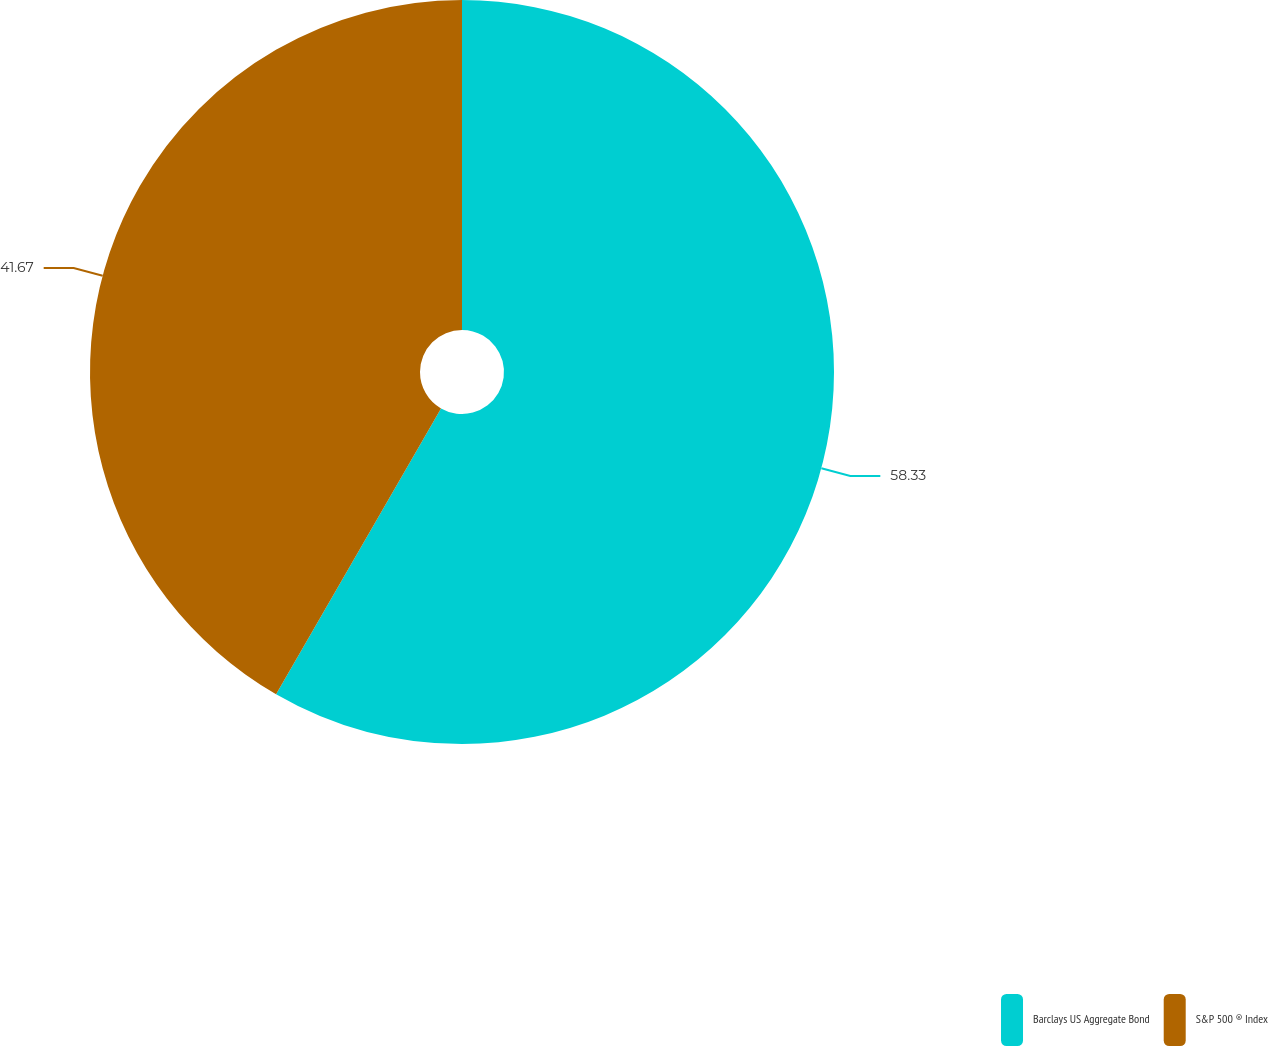<chart> <loc_0><loc_0><loc_500><loc_500><pie_chart><fcel>Barclays US Aggregate Bond<fcel>S&P 500 ® Index<nl><fcel>58.33%<fcel>41.67%<nl></chart> 